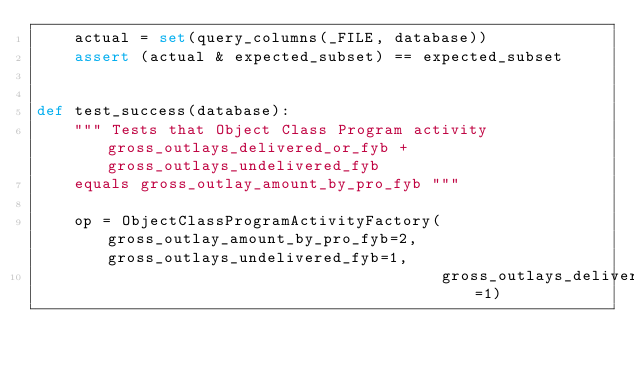<code> <loc_0><loc_0><loc_500><loc_500><_Python_>    actual = set(query_columns(_FILE, database))
    assert (actual & expected_subset) == expected_subset


def test_success(database):
    """ Tests that Object Class Program activity gross_outlays_delivered_or_fyb + gross_outlays_undelivered_fyb
    equals gross_outlay_amount_by_pro_fyb """

    op = ObjectClassProgramActivityFactory(gross_outlay_amount_by_pro_fyb=2, gross_outlays_undelivered_fyb=1,
                                           gross_outlays_delivered_or_fyb=1)
</code> 